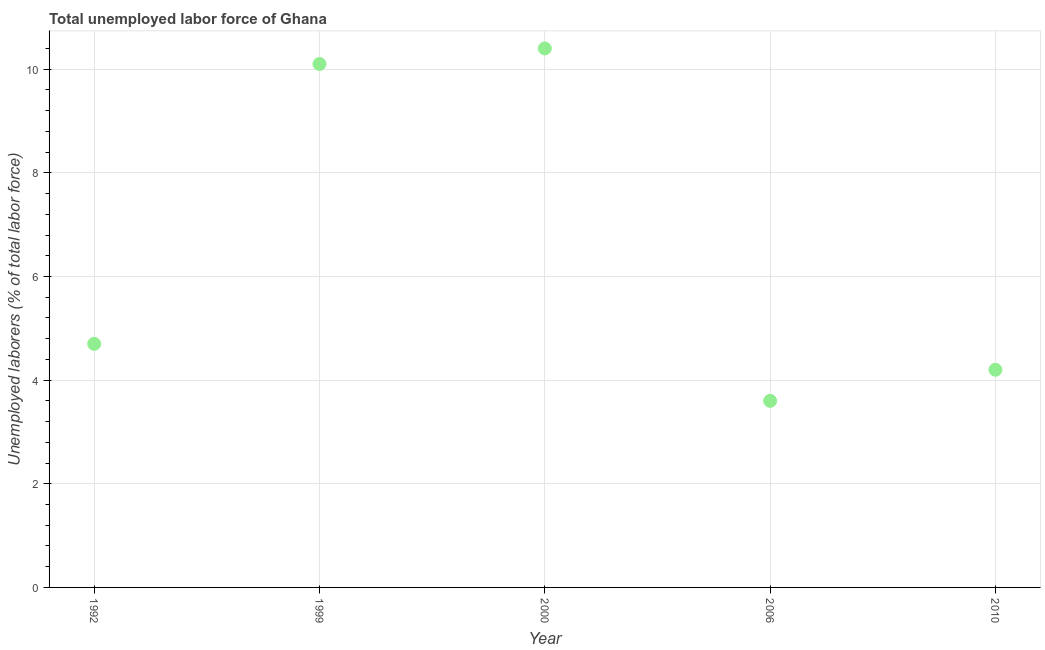What is the total unemployed labour force in 1992?
Make the answer very short. 4.7. Across all years, what is the maximum total unemployed labour force?
Keep it short and to the point. 10.4. Across all years, what is the minimum total unemployed labour force?
Your answer should be very brief. 3.6. What is the sum of the total unemployed labour force?
Offer a very short reply. 33. What is the difference between the total unemployed labour force in 1999 and 2000?
Keep it short and to the point. -0.3. What is the average total unemployed labour force per year?
Ensure brevity in your answer.  6.6. What is the median total unemployed labour force?
Offer a very short reply. 4.7. In how many years, is the total unemployed labour force greater than 8 %?
Offer a very short reply. 2. What is the ratio of the total unemployed labour force in 1992 to that in 1999?
Give a very brief answer. 0.47. What is the difference between the highest and the second highest total unemployed labour force?
Give a very brief answer. 0.3. What is the difference between the highest and the lowest total unemployed labour force?
Offer a very short reply. 6.8. How many years are there in the graph?
Your response must be concise. 5. What is the difference between two consecutive major ticks on the Y-axis?
Your answer should be compact. 2. Does the graph contain any zero values?
Keep it short and to the point. No. What is the title of the graph?
Your answer should be compact. Total unemployed labor force of Ghana. What is the label or title of the X-axis?
Your answer should be very brief. Year. What is the label or title of the Y-axis?
Keep it short and to the point. Unemployed laborers (% of total labor force). What is the Unemployed laborers (% of total labor force) in 1992?
Give a very brief answer. 4.7. What is the Unemployed laborers (% of total labor force) in 1999?
Give a very brief answer. 10.1. What is the Unemployed laborers (% of total labor force) in 2000?
Offer a very short reply. 10.4. What is the Unemployed laborers (% of total labor force) in 2006?
Give a very brief answer. 3.6. What is the Unemployed laborers (% of total labor force) in 2010?
Give a very brief answer. 4.2. What is the difference between the Unemployed laborers (% of total labor force) in 1992 and 1999?
Your response must be concise. -5.4. What is the difference between the Unemployed laborers (% of total labor force) in 1999 and 2000?
Your response must be concise. -0.3. What is the ratio of the Unemployed laborers (% of total labor force) in 1992 to that in 1999?
Provide a succinct answer. 0.47. What is the ratio of the Unemployed laborers (% of total labor force) in 1992 to that in 2000?
Provide a succinct answer. 0.45. What is the ratio of the Unemployed laborers (% of total labor force) in 1992 to that in 2006?
Make the answer very short. 1.31. What is the ratio of the Unemployed laborers (% of total labor force) in 1992 to that in 2010?
Ensure brevity in your answer.  1.12. What is the ratio of the Unemployed laborers (% of total labor force) in 1999 to that in 2006?
Provide a succinct answer. 2.81. What is the ratio of the Unemployed laborers (% of total labor force) in 1999 to that in 2010?
Offer a very short reply. 2.4. What is the ratio of the Unemployed laborers (% of total labor force) in 2000 to that in 2006?
Offer a very short reply. 2.89. What is the ratio of the Unemployed laborers (% of total labor force) in 2000 to that in 2010?
Provide a succinct answer. 2.48. What is the ratio of the Unemployed laborers (% of total labor force) in 2006 to that in 2010?
Provide a succinct answer. 0.86. 